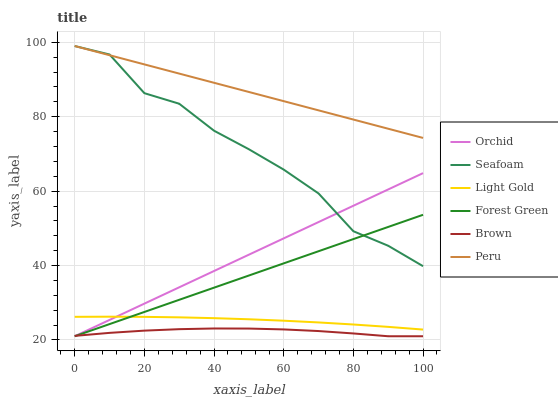Does Brown have the minimum area under the curve?
Answer yes or no. Yes. Does Peru have the maximum area under the curve?
Answer yes or no. Yes. Does Seafoam have the minimum area under the curve?
Answer yes or no. No. Does Seafoam have the maximum area under the curve?
Answer yes or no. No. Is Peru the smoothest?
Answer yes or no. Yes. Is Seafoam the roughest?
Answer yes or no. Yes. Is Forest Green the smoothest?
Answer yes or no. No. Is Forest Green the roughest?
Answer yes or no. No. Does Brown have the lowest value?
Answer yes or no. Yes. Does Seafoam have the lowest value?
Answer yes or no. No. Does Peru have the highest value?
Answer yes or no. Yes. Does Forest Green have the highest value?
Answer yes or no. No. Is Forest Green less than Peru?
Answer yes or no. Yes. Is Peru greater than Light Gold?
Answer yes or no. Yes. Does Seafoam intersect Peru?
Answer yes or no. Yes. Is Seafoam less than Peru?
Answer yes or no. No. Is Seafoam greater than Peru?
Answer yes or no. No. Does Forest Green intersect Peru?
Answer yes or no. No. 